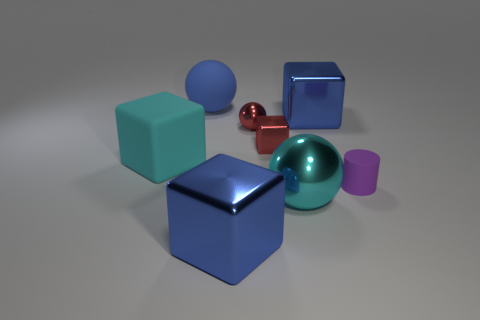What number of cylinders are either big blue matte things or big cyan rubber things? In the image, there are no objects that could be classified as cylinders, so the number of cylinders that are either big blue matte things or big cyan rubber things is zero. 